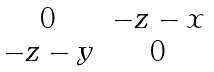Convert formula to latex. <formula><loc_0><loc_0><loc_500><loc_500>\begin{matrix} 0 & - z - x \\ - z - y & 0 \end{matrix}</formula> 